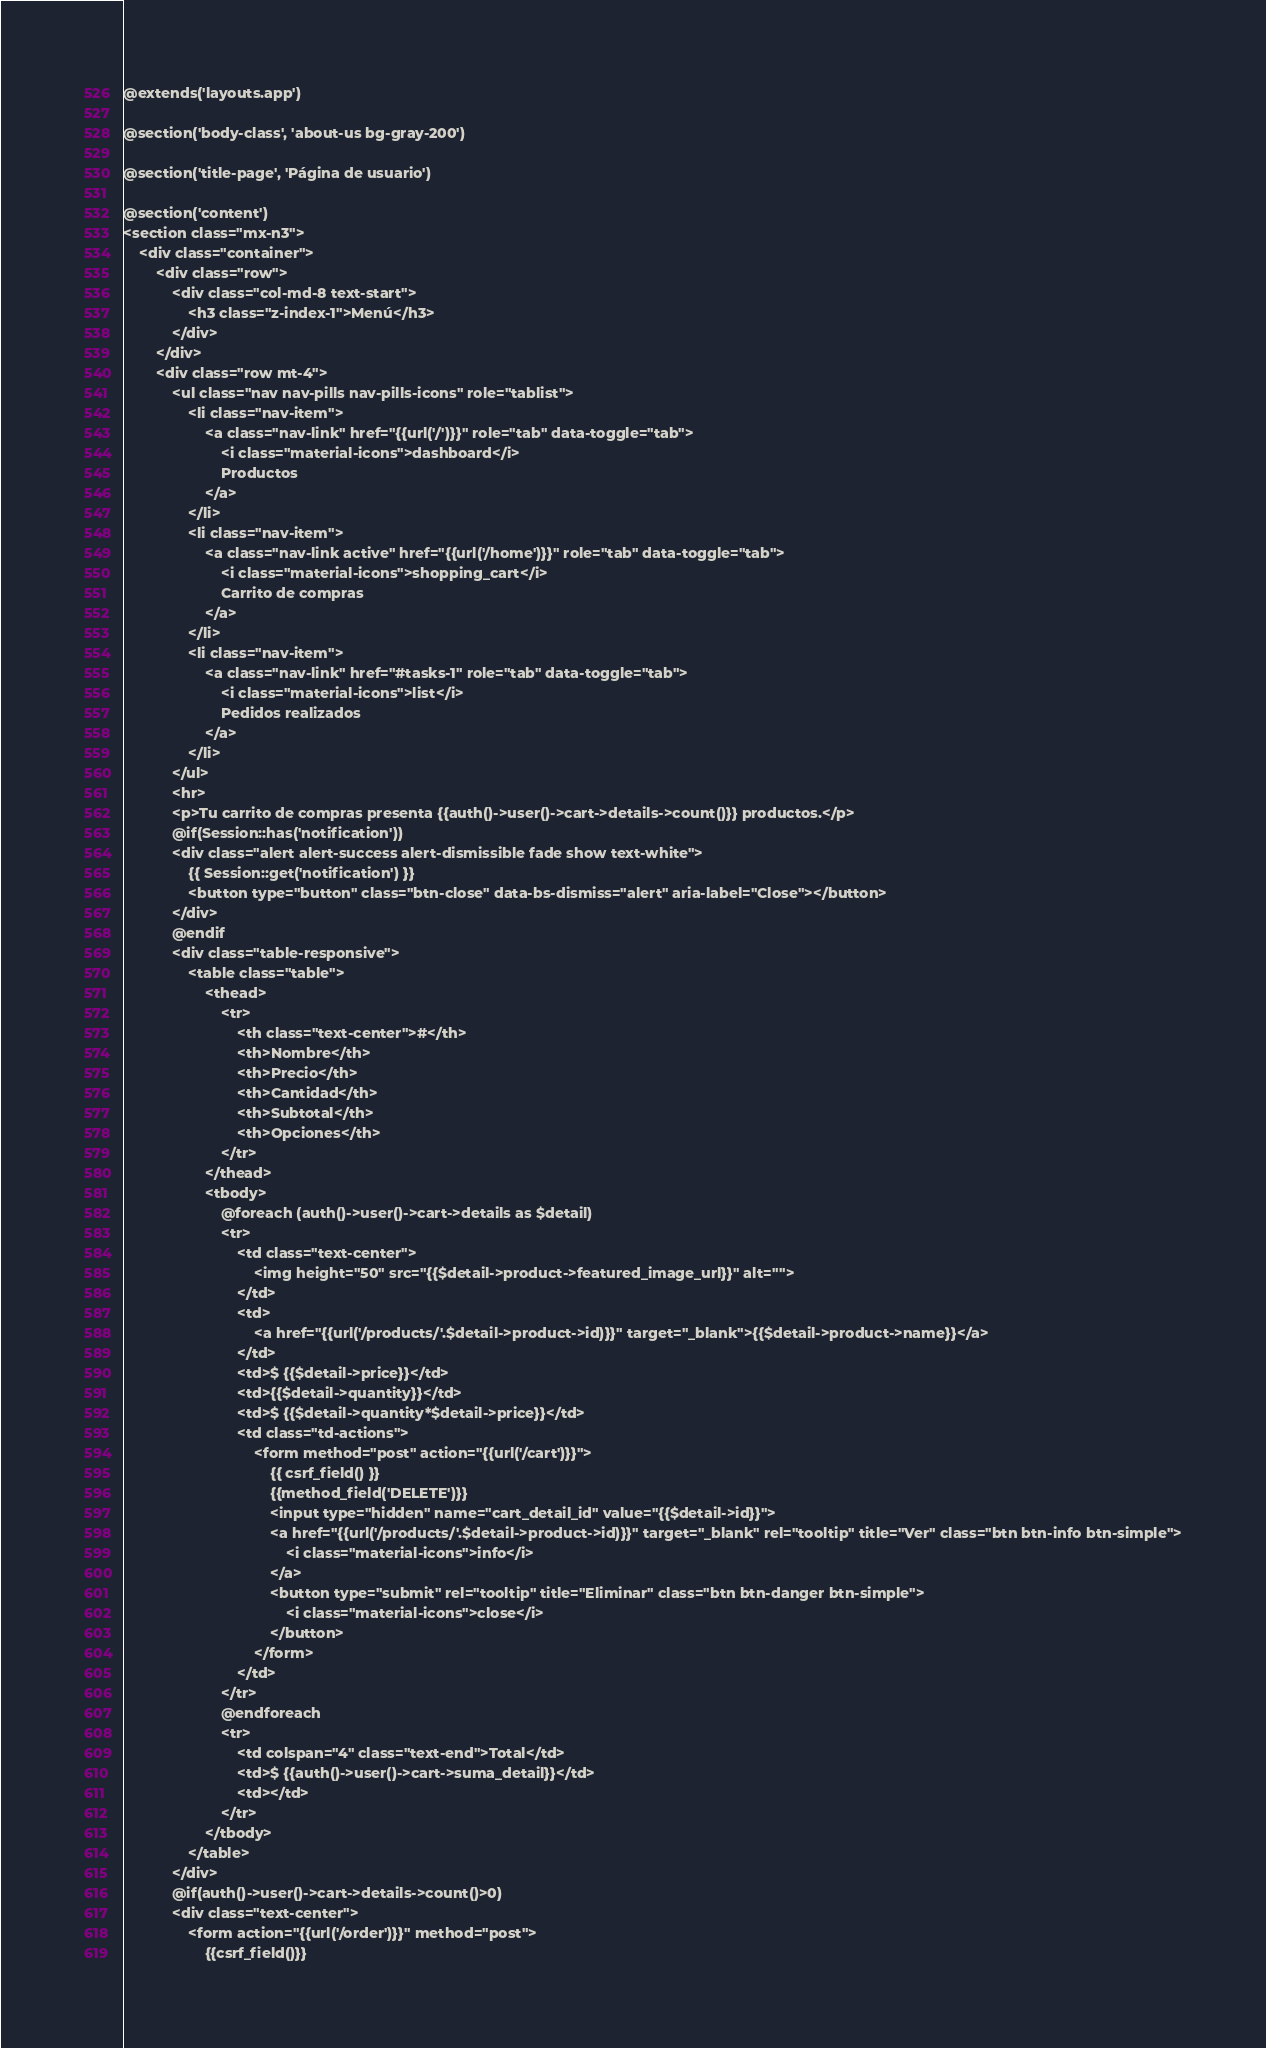Convert code to text. <code><loc_0><loc_0><loc_500><loc_500><_PHP_>@extends('layouts.app')

@section('body-class', 'about-us bg-gray-200')

@section('title-page', 'Página de usuario')

@section('content')
<section class="mx-n3">
    <div class="container">
        <div class="row">
            <div class="col-md-8 text-start">
                <h3 class="z-index-1">Menú</h3>
            </div>
        </div>
        <div class="row mt-4">
            <ul class="nav nav-pills nav-pills-icons" role="tablist">
                <li class="nav-item">
                    <a class="nav-link" href="{{url('/')}}" role="tab" data-toggle="tab">
                        <i class="material-icons">dashboard</i>
                        Productos
                    </a>
                </li>
                <li class="nav-item">
                    <a class="nav-link active" href="{{url('/home')}}" role="tab" data-toggle="tab">
                        <i class="material-icons">shopping_cart</i>
                        Carrito de compras
                    </a>
                </li>
                <li class="nav-item">
                    <a class="nav-link" href="#tasks-1" role="tab" data-toggle="tab">
                        <i class="material-icons">list</i>
                        Pedidos realizados
                    </a>
                </li>
            </ul>
            <hr>
            <p>Tu carrito de compras presenta {{auth()->user()->cart->details->count()}} productos.</p>
            @if(Session::has('notification'))
            <div class="alert alert-success alert-dismissible fade show text-white">
                {{ Session::get('notification') }}
                <button type="button" class="btn-close" data-bs-dismiss="alert" aria-label="Close"></button>
            </div>
            @endif
            <div class="table-responsive">
                <table class="table">
                    <thead>
                        <tr>
                            <th class="text-center">#</th>
                            <th>Nombre</th>
                            <th>Precio</th>
                            <th>Cantidad</th>
                            <th>Subtotal</th>
                            <th>Opciones</th>
                        </tr>
                    </thead>
                    <tbody>
                        @foreach (auth()->user()->cart->details as $detail)
                        <tr>
                            <td class="text-center">
                                <img height="50" src="{{$detail->product->featured_image_url}}" alt="">
                            </td>
                            <td>
                                <a href="{{url('/products/'.$detail->product->id)}}" target="_blank">{{$detail->product->name}}</a>
                            </td>
                            <td>$ {{$detail->price}}</td>
                            <td>{{$detail->quantity}}</td>
                            <td>$ {{$detail->quantity*$detail->price}}</td>
                            <td class="td-actions">
                                <form method="post" action="{{url('/cart')}}">
                                    {{ csrf_field() }}
                                    {{method_field('DELETE')}}
                                    <input type="hidden" name="cart_detail_id" value="{{$detail->id}}">
                                    <a href="{{url('/products/'.$detail->product->id)}}" target="_blank" rel="tooltip" title="Ver" class="btn btn-info btn-simple">
                                        <i class="material-icons">info</i>
                                    </a>
                                    <button type="submit" rel="tooltip" title="Eliminar" class="btn btn-danger btn-simple">
                                        <i class="material-icons">close</i>
                                    </button>
                                </form>
                            </td>
                        </tr>
                        @endforeach
                        <tr>
                            <td colspan="4" class="text-end">Total</td>
                            <td>$ {{auth()->user()->cart->suma_detail}}</td>
                            <td></td>
                        </tr>
                    </tbody>
                </table>
            </div>
            @if(auth()->user()->cart->details->count()>0)
            <div class="text-center">
                <form action="{{url('/order')}}" method="post">
                    {{csrf_field()}}</code> 